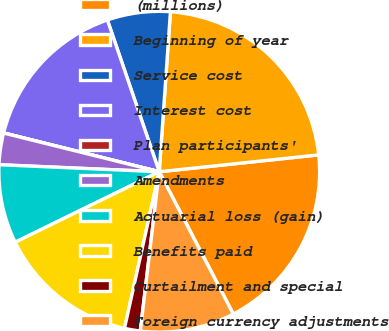Convert chart. <chart><loc_0><loc_0><loc_500><loc_500><pie_chart><fcel>(millions)<fcel>Beginning of year<fcel>Service cost<fcel>Interest cost<fcel>Plan participants'<fcel>Amendments<fcel>Actuarial loss (gain)<fcel>Benefits paid<fcel>Curtailment and special<fcel>Foreign currency adjustments<nl><fcel>19.04%<fcel>22.21%<fcel>6.35%<fcel>15.87%<fcel>0.01%<fcel>3.18%<fcel>7.94%<fcel>14.28%<fcel>1.59%<fcel>9.52%<nl></chart> 